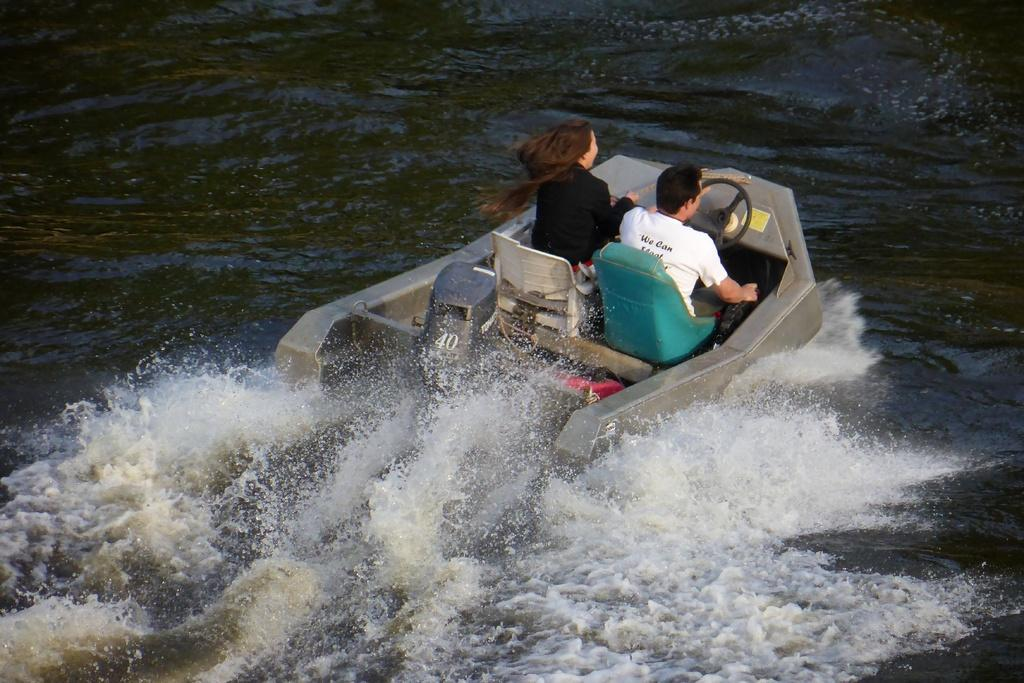What type of watercraft is in the foreground of the image? There is a skiff boat in the foreground of the image. How many people are in the boat? Two persons are sitting in the boat. What is the boat doing in the image? The boat is moving on the water. What type of drink is being served in the garden in the image? There is no garden or drink present in the image; it features a skiff boat with two persons on the water. 